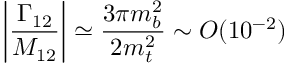<formula> <loc_0><loc_0><loc_500><loc_500>\left | \frac { \Gamma _ { 1 2 } } { M _ { 1 2 } } \right | \simeq \frac { 3 \pi m _ { b } ^ { 2 } } { 2 m _ { t } ^ { 2 } } \sim O ( 1 0 ^ { - 2 } )</formula> 